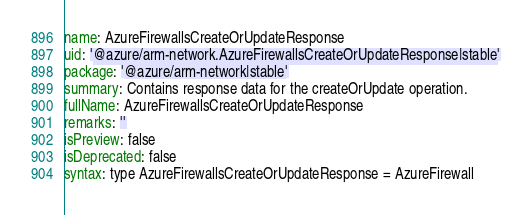<code> <loc_0><loc_0><loc_500><loc_500><_YAML_>name: AzureFirewallsCreateOrUpdateResponse
uid: '@azure/arm-network.AzureFirewallsCreateOrUpdateResponse|stable'
package: '@azure/arm-network|stable'
summary: Contains response data for the createOrUpdate operation.
fullName: AzureFirewallsCreateOrUpdateResponse
remarks: ''
isPreview: false
isDeprecated: false
syntax: type AzureFirewallsCreateOrUpdateResponse = AzureFirewall
</code> 